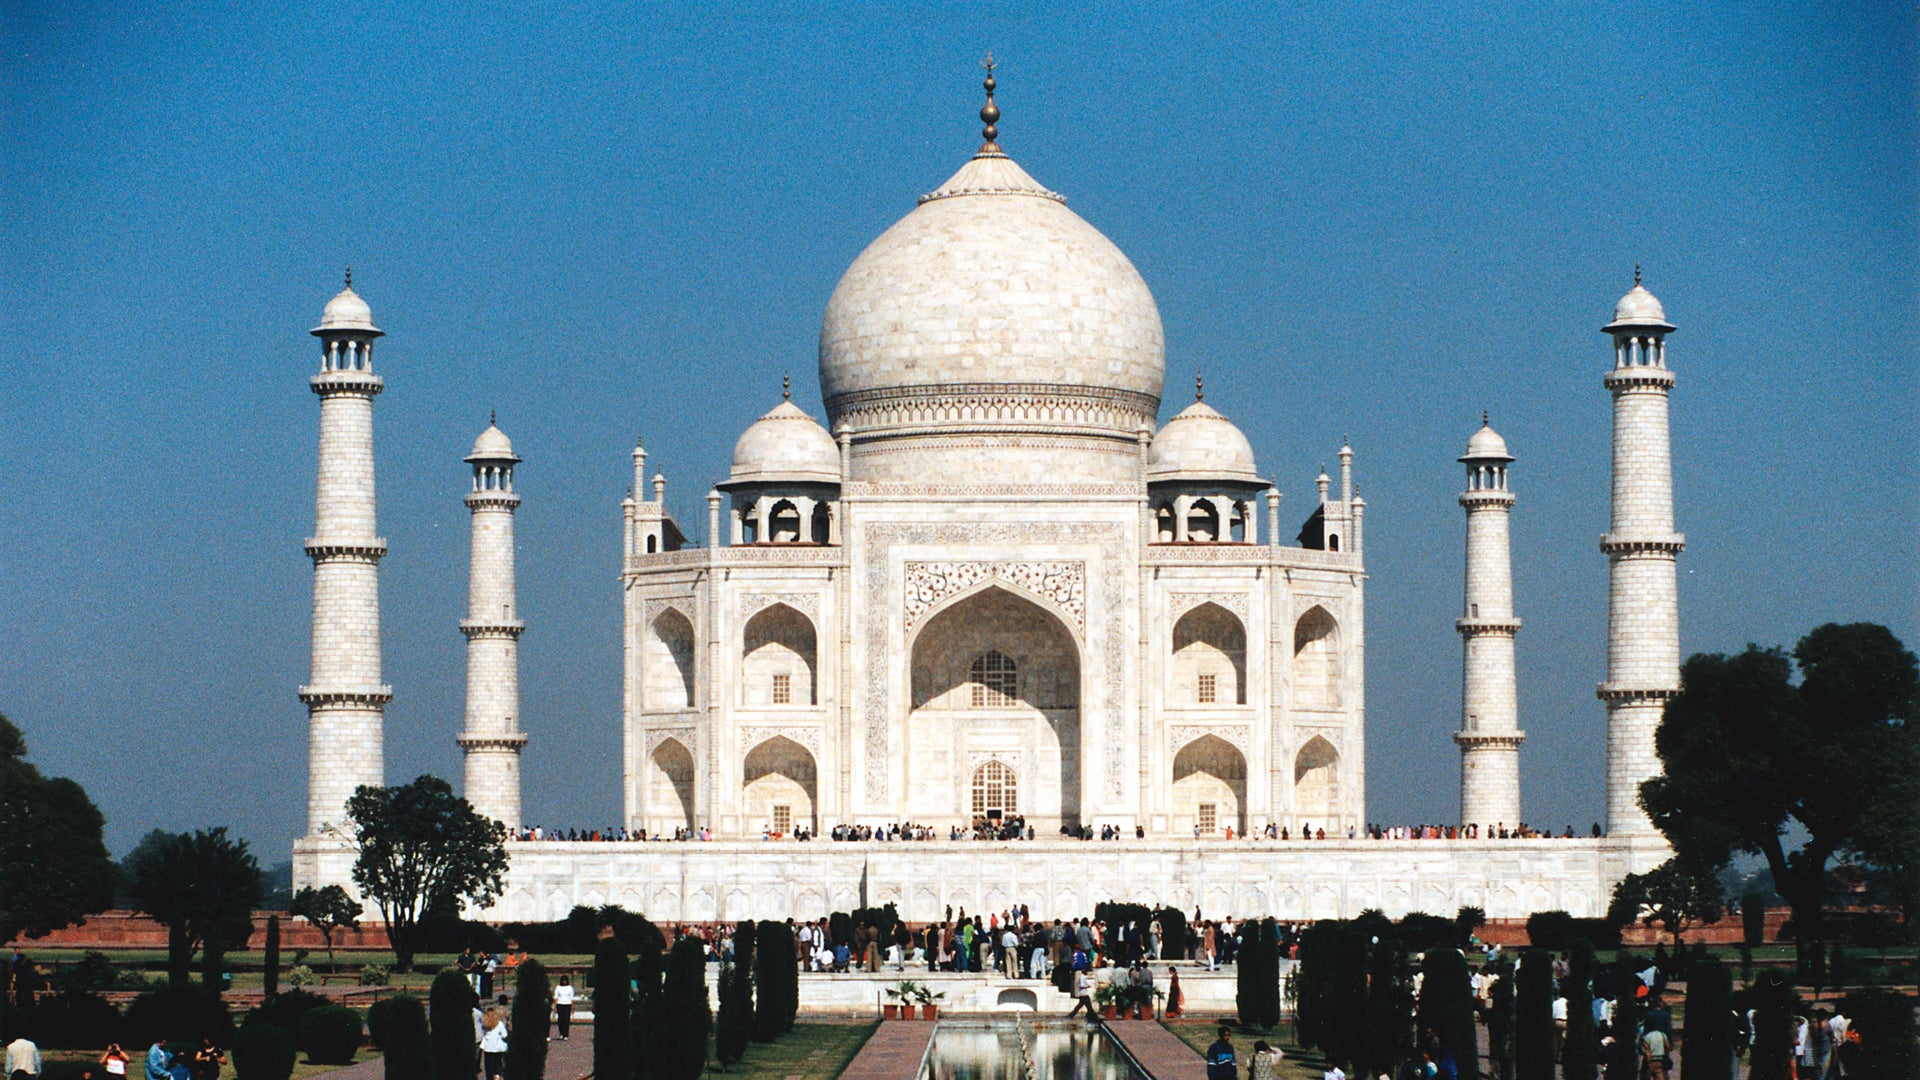Can you describe the main features of this image for me? Certainly! This image features the iconic Taj Mahal, situated in Agra, India. Built by the Mughal Emperor Shah Jahan in memory of his beloved wife, Mumtaz Mahal, this ivory-white marble mausoleum exemplifies the pinnacle of Mughal architecture. The main structure stands on a square plinth and is topped with a symmetrical dome flanked by four slender minarets. Intricate calligraphy and detailed inlay work adorn the facade, showcasing the craftsmanship of the artisans. Below, a long reflecting pool leads to the main gate, offering visitors a mesmerizing perspective of the monument. Lush gardens and lawns spread around the complex, complementing the sheer elegance of the mausoleum. The serene blue sky above creates a peaceful ambiance, while visitors dotting the grounds give a sense of scale to this architectural masterpiece. 